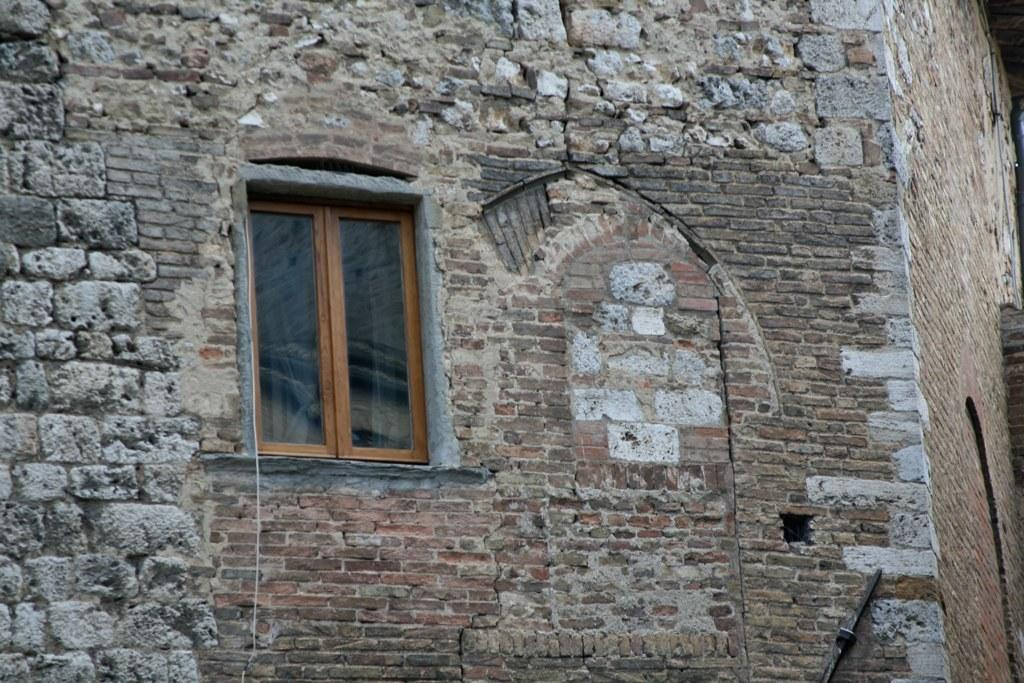What is present on the wall in the image? There is a window on the wall in the image. Can you describe the window on the wall? The window is on the wall in the image. What type of shop can be seen on the page in the image? There is no shop or page present in the image; it only features a wall with a window on it. 